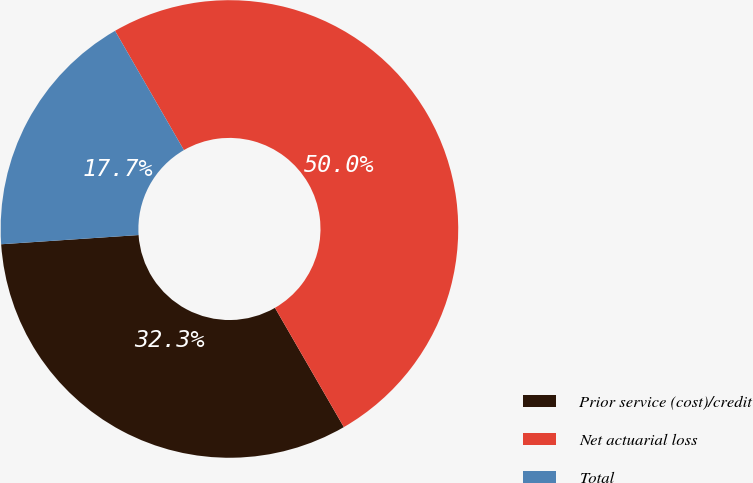<chart> <loc_0><loc_0><loc_500><loc_500><pie_chart><fcel>Prior service (cost)/credit<fcel>Net actuarial loss<fcel>Total<nl><fcel>32.27%<fcel>50.0%<fcel>17.73%<nl></chart> 